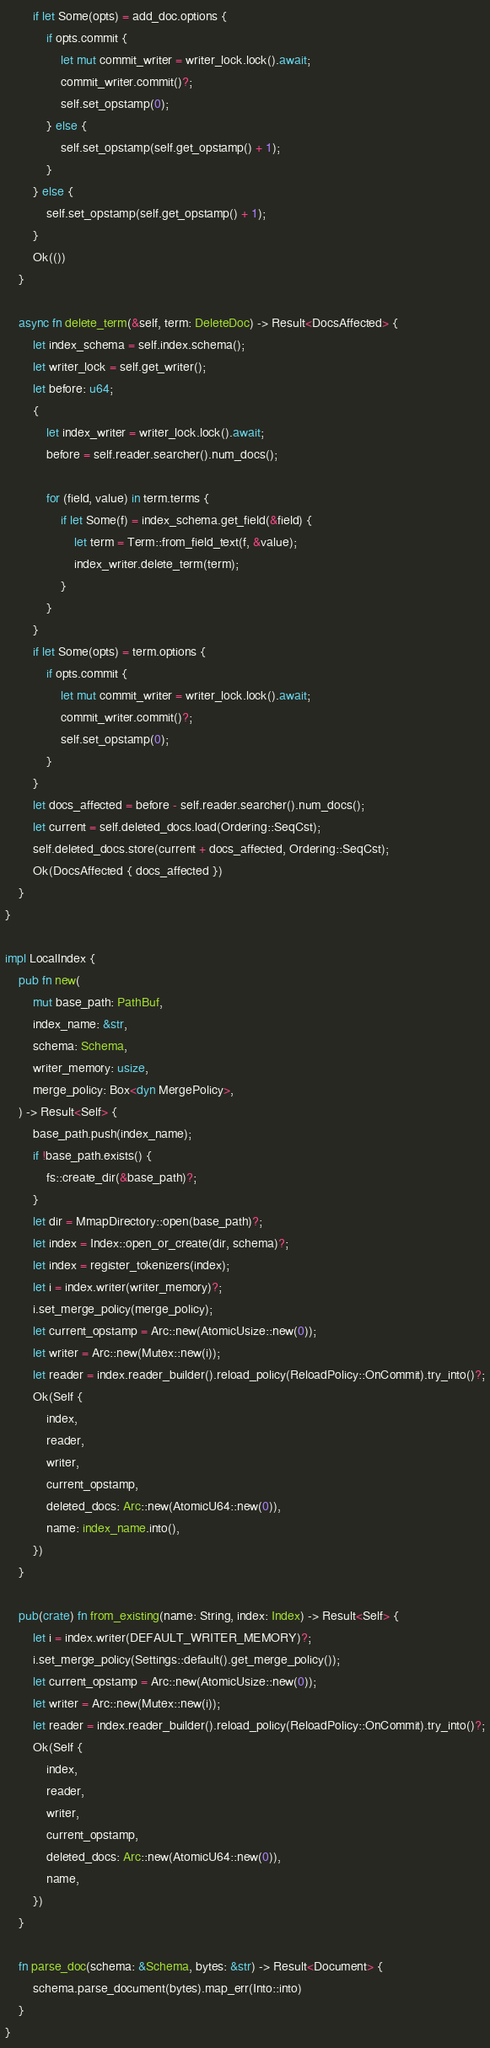Convert code to text. <code><loc_0><loc_0><loc_500><loc_500><_Rust_>        if let Some(opts) = add_doc.options {
            if opts.commit {
                let mut commit_writer = writer_lock.lock().await;
                commit_writer.commit()?;
                self.set_opstamp(0);
            } else {
                self.set_opstamp(self.get_opstamp() + 1);
            }
        } else {
            self.set_opstamp(self.get_opstamp() + 1);
        }
        Ok(())
    }

    async fn delete_term(&self, term: DeleteDoc) -> Result<DocsAffected> {
        let index_schema = self.index.schema();
        let writer_lock = self.get_writer();
        let before: u64;
        {
            let index_writer = writer_lock.lock().await;
            before = self.reader.searcher().num_docs();

            for (field, value) in term.terms {
                if let Some(f) = index_schema.get_field(&field) {
                    let term = Term::from_field_text(f, &value);
                    index_writer.delete_term(term);
                }
            }
        }
        if let Some(opts) = term.options {
            if opts.commit {
                let mut commit_writer = writer_lock.lock().await;
                commit_writer.commit()?;
                self.set_opstamp(0);
            }
        }
        let docs_affected = before - self.reader.searcher().num_docs();
        let current = self.deleted_docs.load(Ordering::SeqCst);
        self.deleted_docs.store(current + docs_affected, Ordering::SeqCst);
        Ok(DocsAffected { docs_affected })
    }
}

impl LocalIndex {
    pub fn new(
        mut base_path: PathBuf,
        index_name: &str,
        schema: Schema,
        writer_memory: usize,
        merge_policy: Box<dyn MergePolicy>,
    ) -> Result<Self> {
        base_path.push(index_name);
        if !base_path.exists() {
            fs::create_dir(&base_path)?;
        }
        let dir = MmapDirectory::open(base_path)?;
        let index = Index::open_or_create(dir, schema)?;
        let index = register_tokenizers(index);
        let i = index.writer(writer_memory)?;
        i.set_merge_policy(merge_policy);
        let current_opstamp = Arc::new(AtomicUsize::new(0));
        let writer = Arc::new(Mutex::new(i));
        let reader = index.reader_builder().reload_policy(ReloadPolicy::OnCommit).try_into()?;
        Ok(Self {
            index,
            reader,
            writer,
            current_opstamp,
            deleted_docs: Arc::new(AtomicU64::new(0)),
            name: index_name.into(),
        })
    }

    pub(crate) fn from_existing(name: String, index: Index) -> Result<Self> {
        let i = index.writer(DEFAULT_WRITER_MEMORY)?;
        i.set_merge_policy(Settings::default().get_merge_policy());
        let current_opstamp = Arc::new(AtomicUsize::new(0));
        let writer = Arc::new(Mutex::new(i));
        let reader = index.reader_builder().reload_policy(ReloadPolicy::OnCommit).try_into()?;
        Ok(Self {
            index,
            reader,
            writer,
            current_opstamp,
            deleted_docs: Arc::new(AtomicU64::new(0)),
            name,
        })
    }

    fn parse_doc(schema: &Schema, bytes: &str) -> Result<Document> {
        schema.parse_document(bytes).map_err(Into::into)
    }
}
</code> 